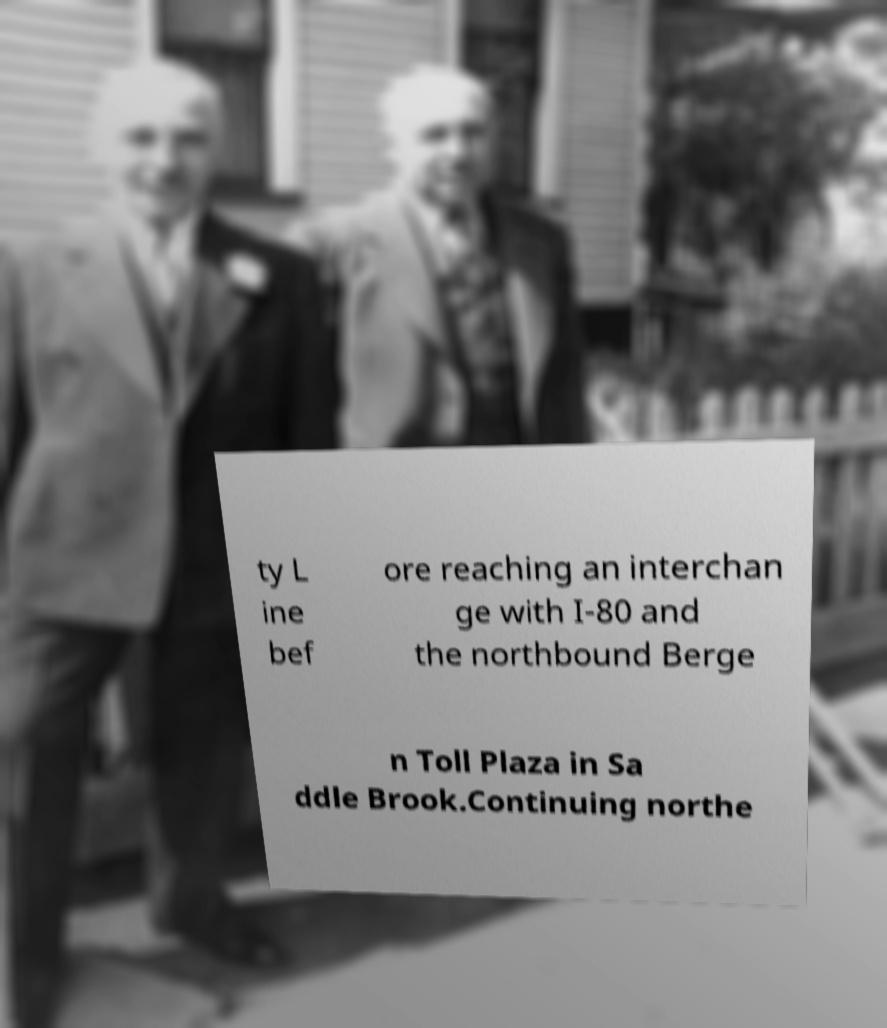Can you read and provide the text displayed in the image?This photo seems to have some interesting text. Can you extract and type it out for me? ty L ine bef ore reaching an interchan ge with I-80 and the northbound Berge n Toll Plaza in Sa ddle Brook.Continuing northe 